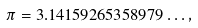Convert formula to latex. <formula><loc_0><loc_0><loc_500><loc_500>\pi = 3 . 1 4 1 5 9 2 6 5 3 5 8 9 7 9 \dots ,</formula> 